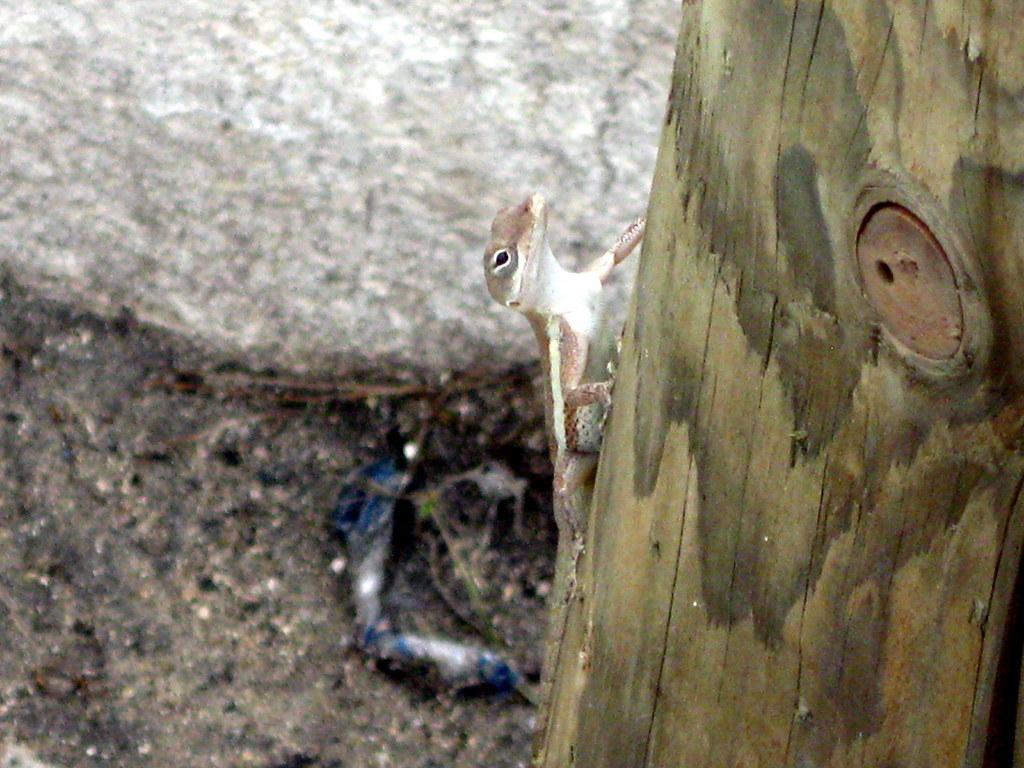Can you describe this image briefly? In this picture we can observe a lizard which is in white and cream color on the wooden object. In the background we can observe large stone and a ground. 